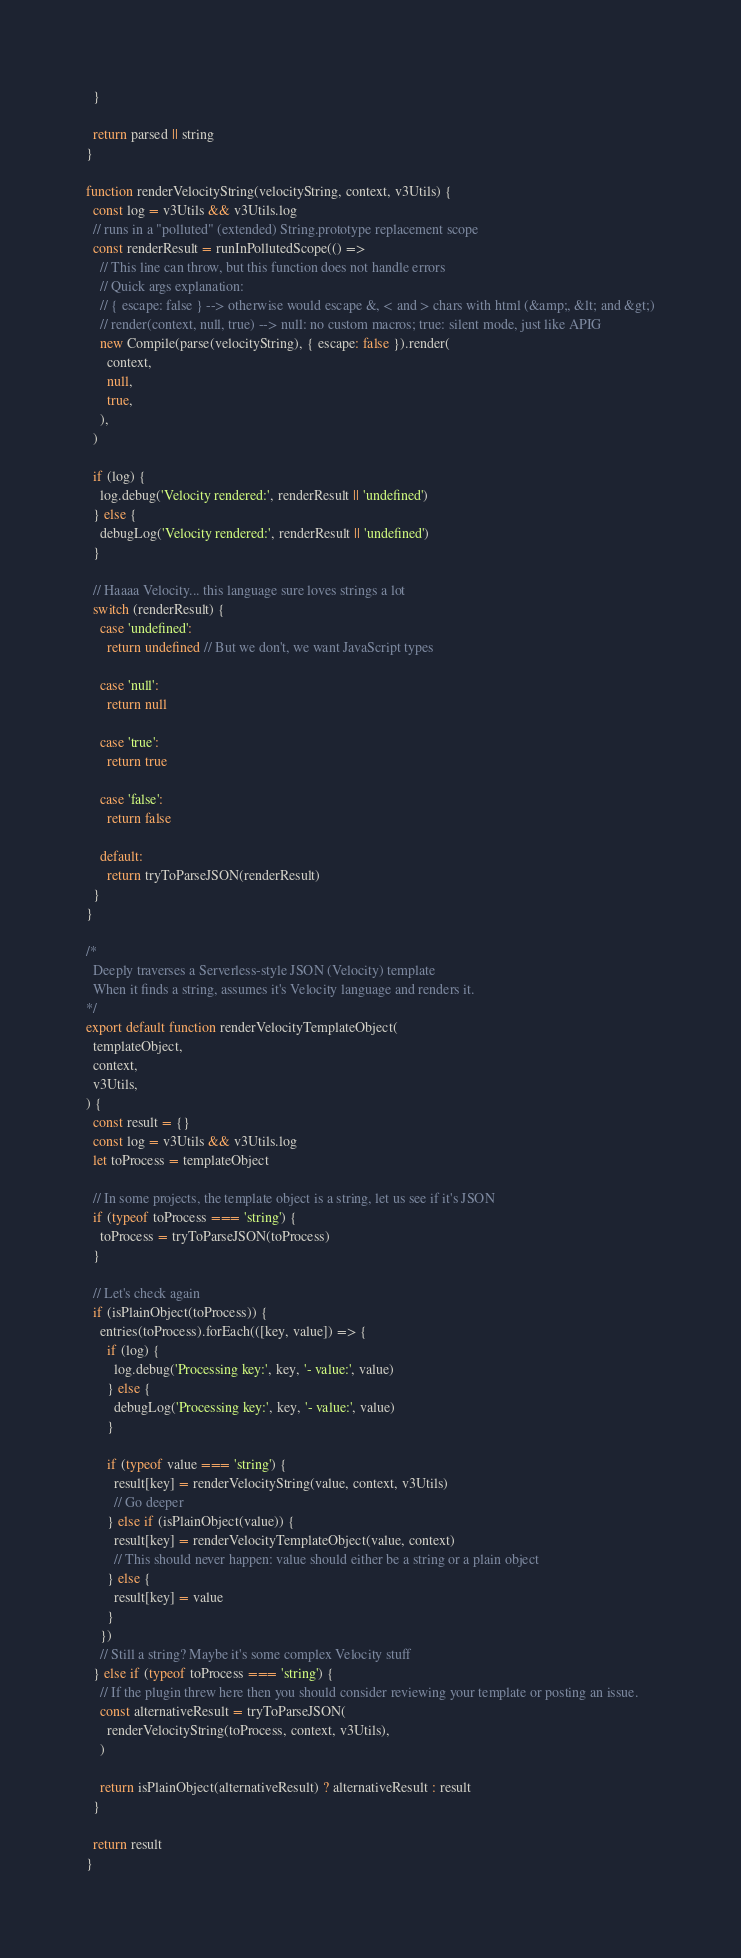<code> <loc_0><loc_0><loc_500><loc_500><_JavaScript_>  }

  return parsed || string
}

function renderVelocityString(velocityString, context, v3Utils) {
  const log = v3Utils && v3Utils.log
  // runs in a "polluted" (extended) String.prototype replacement scope
  const renderResult = runInPollutedScope(() =>
    // This line can throw, but this function does not handle errors
    // Quick args explanation:
    // { escape: false } --> otherwise would escape &, < and > chars with html (&amp;, &lt; and &gt;)
    // render(context, null, true) --> null: no custom macros; true: silent mode, just like APIG
    new Compile(parse(velocityString), { escape: false }).render(
      context,
      null,
      true,
    ),
  )

  if (log) {
    log.debug('Velocity rendered:', renderResult || 'undefined')
  } else {
    debugLog('Velocity rendered:', renderResult || 'undefined')
  }

  // Haaaa Velocity... this language sure loves strings a lot
  switch (renderResult) {
    case 'undefined':
      return undefined // But we don't, we want JavaScript types

    case 'null':
      return null

    case 'true':
      return true

    case 'false':
      return false

    default:
      return tryToParseJSON(renderResult)
  }
}

/*
  Deeply traverses a Serverless-style JSON (Velocity) template
  When it finds a string, assumes it's Velocity language and renders it.
*/
export default function renderVelocityTemplateObject(
  templateObject,
  context,
  v3Utils,
) {
  const result = {}
  const log = v3Utils && v3Utils.log
  let toProcess = templateObject

  // In some projects, the template object is a string, let us see if it's JSON
  if (typeof toProcess === 'string') {
    toProcess = tryToParseJSON(toProcess)
  }

  // Let's check again
  if (isPlainObject(toProcess)) {
    entries(toProcess).forEach(([key, value]) => {
      if (log) {
        log.debug('Processing key:', key, '- value:', value)
      } else {
        debugLog('Processing key:', key, '- value:', value)
      }

      if (typeof value === 'string') {
        result[key] = renderVelocityString(value, context, v3Utils)
        // Go deeper
      } else if (isPlainObject(value)) {
        result[key] = renderVelocityTemplateObject(value, context)
        // This should never happen: value should either be a string or a plain object
      } else {
        result[key] = value
      }
    })
    // Still a string? Maybe it's some complex Velocity stuff
  } else if (typeof toProcess === 'string') {
    // If the plugin threw here then you should consider reviewing your template or posting an issue.
    const alternativeResult = tryToParseJSON(
      renderVelocityString(toProcess, context, v3Utils),
    )

    return isPlainObject(alternativeResult) ? alternativeResult : result
  }

  return result
}
</code> 